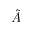<formula> <loc_0><loc_0><loc_500><loc_500>\tilde { A }</formula> 